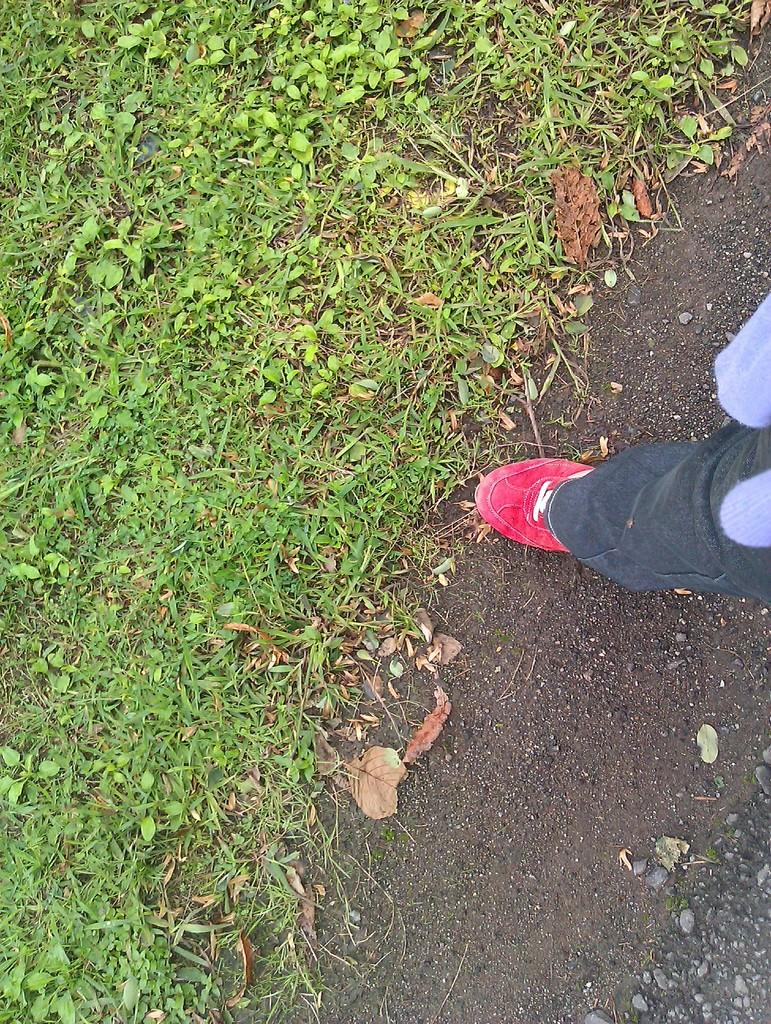What is the main subject of the image? The main subject of the image is a person standing on the right side of the image. Where is the person standing? The person is standing on the road. What type of surface is in front of the person? There is grass on the surface in front of the person. What type of mint can be seen growing on the person's clothing in the image? There is no mint visible on the person's clothing in the image. 